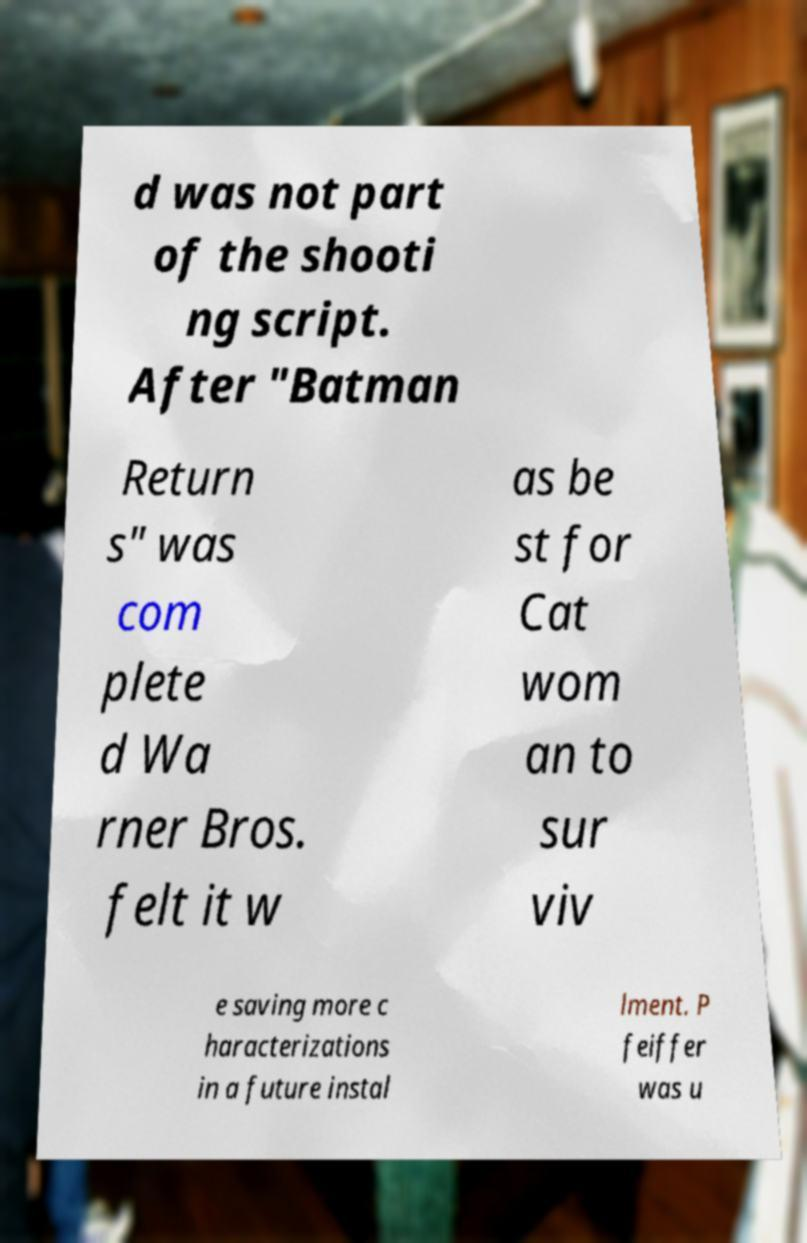There's text embedded in this image that I need extracted. Can you transcribe it verbatim? d was not part of the shooti ng script. After "Batman Return s" was com plete d Wa rner Bros. felt it w as be st for Cat wom an to sur viv e saving more c haracterizations in a future instal lment. P feiffer was u 